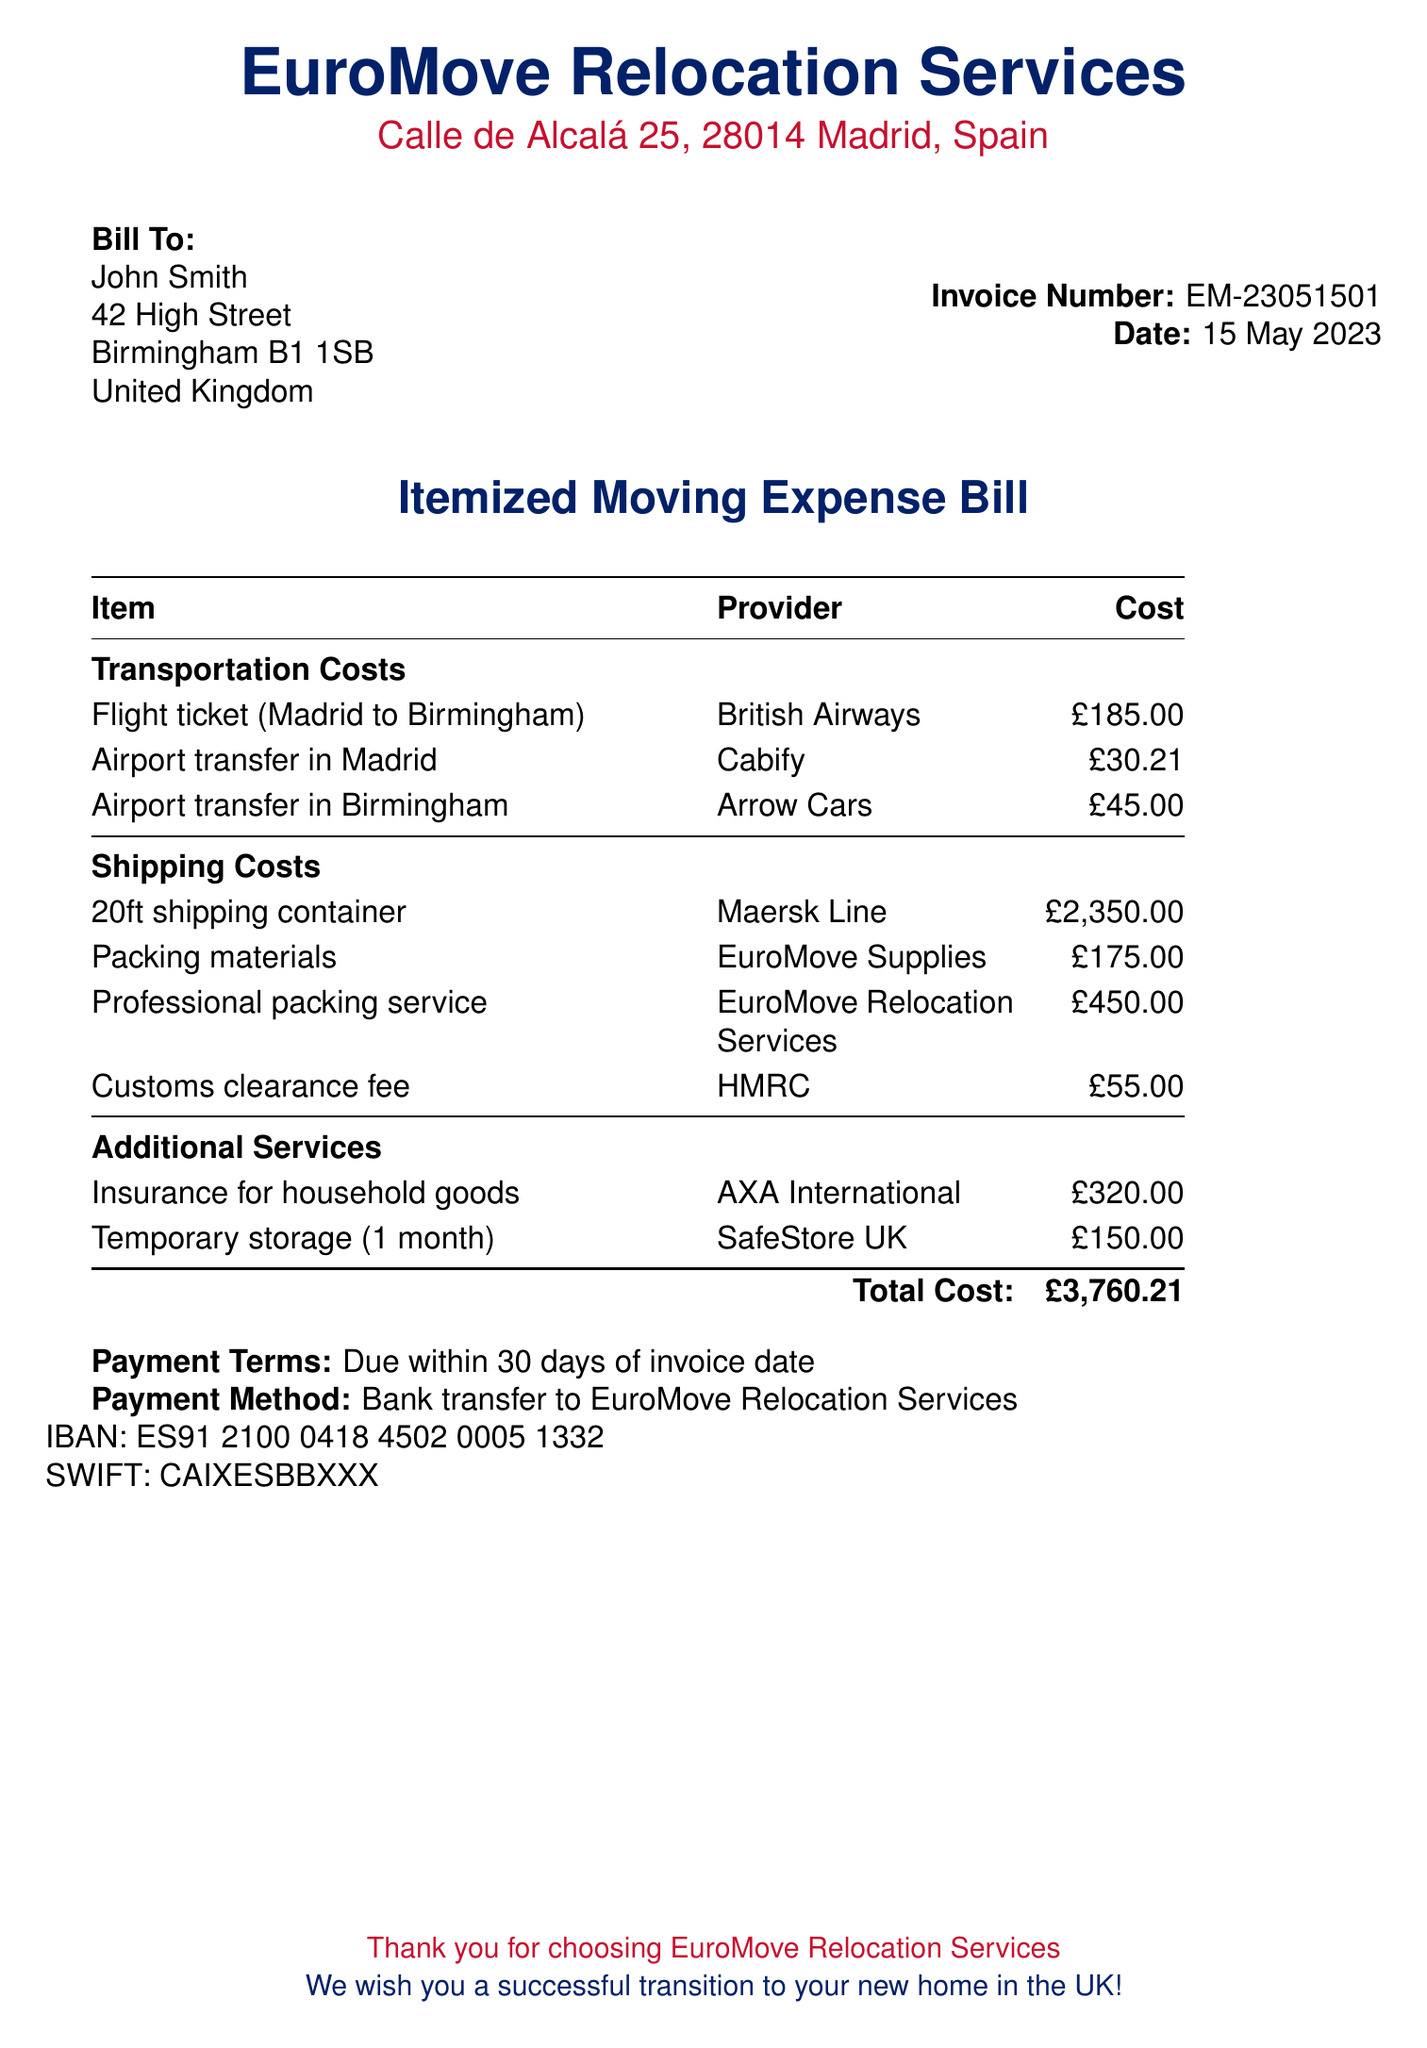What is the total cost of the relocation? The total cost is listed at the bottom of the bill, summarizing all expenses incurred during the relocation process.
Answer: £3,760.21 Who provided the flight ticket? The provider of the flight ticket for the relocation is mentioned next to the item.
Answer: British Airways What is the invoice number? The invoice number is a unique identifier for this specific bill, typically found in the header section of the document.
Answer: EM-23051501 What is the date of the invoice? The date reflects when this invoice was issued and is located alongside the invoice number.
Answer: 15 May 2023 How much was paid for the packing materials? The cost of packing materials is specified in the shipping costs section of the bill.
Answer: £175.00 What type of container was used for shipping? The bill specifies the type of shipping container used in the relevant section.
Answer: 20ft shipping container What payment method is accepted for this invoice? The payment method section indicates how the payment should be made for the services listed in the bill.
Answer: Bank transfer What is the name of the insurance provider? The name of the insurance provider that covered household goods is found in the additional services section of the bill.
Answer: AXA International How long is the temporary storage service charged for? The duration of temporary storage service mentioned in the bill provides relevant information about what is being billed.
Answer: 1 month 